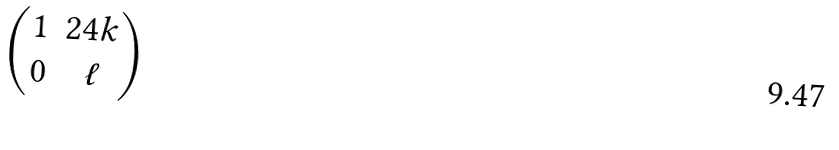<formula> <loc_0><loc_0><loc_500><loc_500>\begin{pmatrix} 1 & 2 4 k \\ 0 & \ell \end{pmatrix}</formula> 